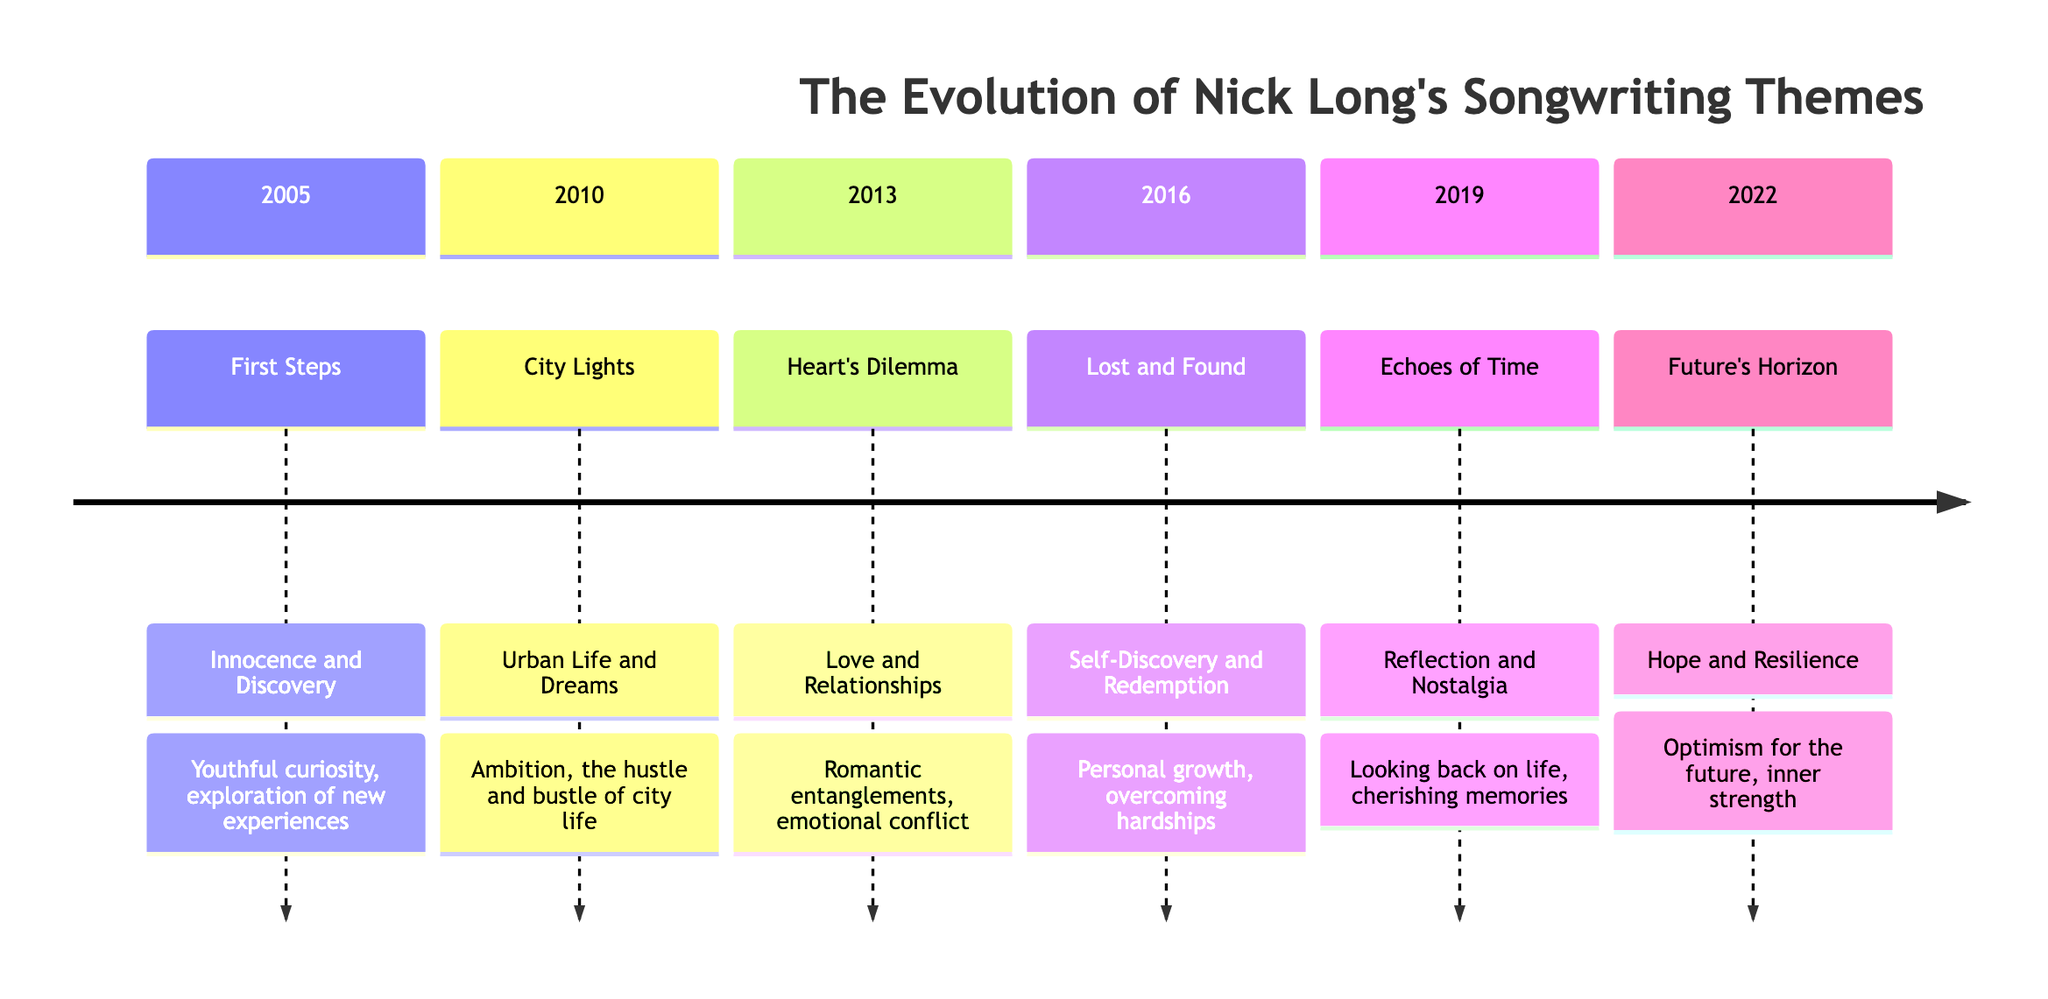What is the first song listed in the timeline? The timeline begins with the song "First Steps," which is in the section labeled 2005.
Answer: First Steps How many significant songs are featured in the timeline? By counting the section entries, there are six significant songs listed in the timeline, from 2005 to 2022.
Answer: 6 What lyrical motif is associated with the song "Heart's Dilemma"? The song "Heart's Dilemma," from the section of 2013, is associated with the motif of romantic entanglements and emotional conflict.
Answer: Love and Relationships Which year corresponds to the theme of self-discovery and redemption? Referring to the timeline, the year 2016 corresponds to the theme of self-discovery and redemption, as indicated by the song "Lost and Found."
Answer: 2016 What does the section titled "Future's Horizon" represent? The section titled "Future's Horizon," from 2022, represents themes of optimism for the future and inner strength, as depicted in the description.
Answer: Hope and Resilience Which song speaks to the theme of reflection and nostalgia? The song "Echoes of Time," from the year 2019, speaks to the theme of reflection and nostalgia based on the section description.
Answer: Echoes of Time How does the theme evolve from 2013 to 2016? The theme evolves from love and relationships in 2013 with "Heart's Dilemma" to self-discovery and redemption in 2016 with "Lost and Found," indicating a shift from romantic issues to personal growth challenges.
Answer: Transition from love to self-discovery What musical motif is prevalent in the 2010 section? The 2010 section features the motif of urban life and dreams as exemplified by the song "City Lights."
Answer: Urban Life and Dreams Name the song from the 2019 section. The song listed in the 2019 section is "Echoes of Time."
Answer: Echoes of Time 